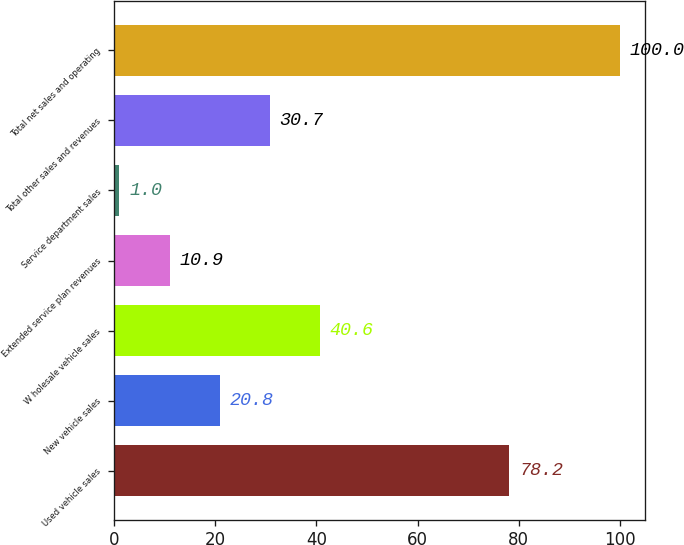<chart> <loc_0><loc_0><loc_500><loc_500><bar_chart><fcel>Used vehicle sales<fcel>New vehicle sales<fcel>W holesale vehicle sales<fcel>Extended service plan revenues<fcel>Service department sales<fcel>Total other sales and revenues<fcel>Total net sales and operating<nl><fcel>78.2<fcel>20.8<fcel>40.6<fcel>10.9<fcel>1<fcel>30.7<fcel>100<nl></chart> 